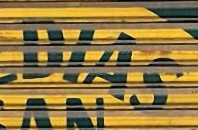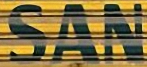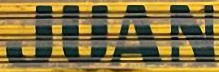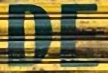What text appears in these images from left to right, separated by a semicolon? DIAS; SAN; JUAN; DE 